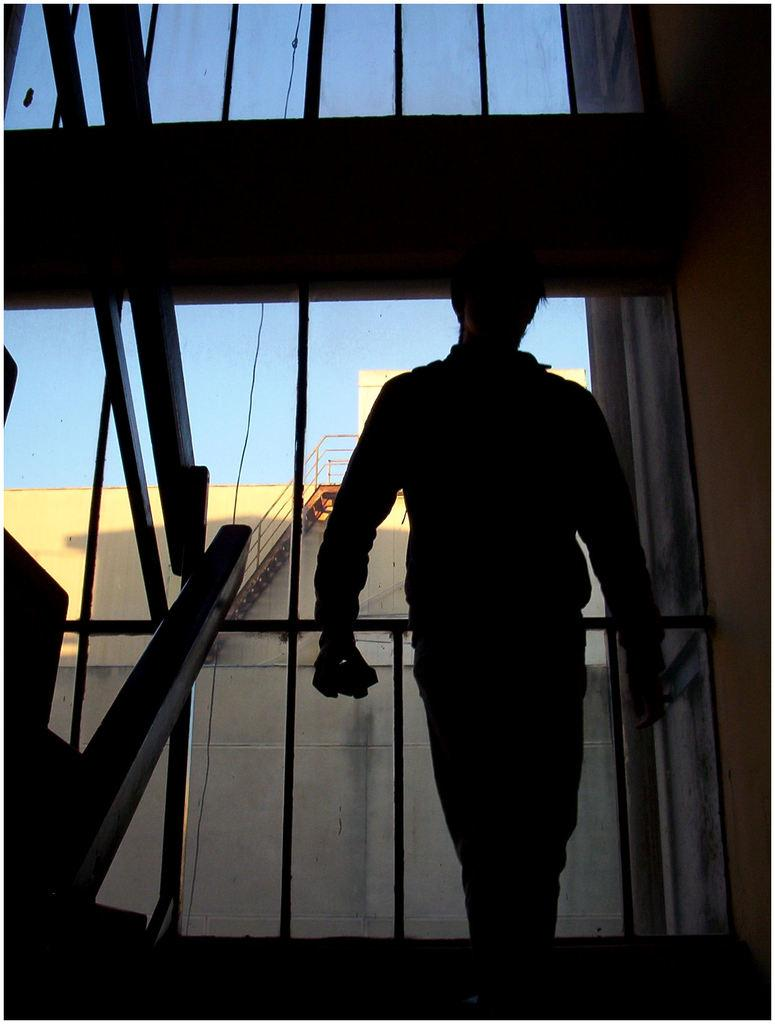What is the main subject of the image? There is a person standing in the image. What can be seen in the background of the image? There is a framed glass wall, a building, a ladder, and the sky visible in the background of the image. What news is being reported on the hour in the image? There is no news or hourly report present in the image; it features a person standing in front of a framed glass wall, a building, a ladder, and the sky. 